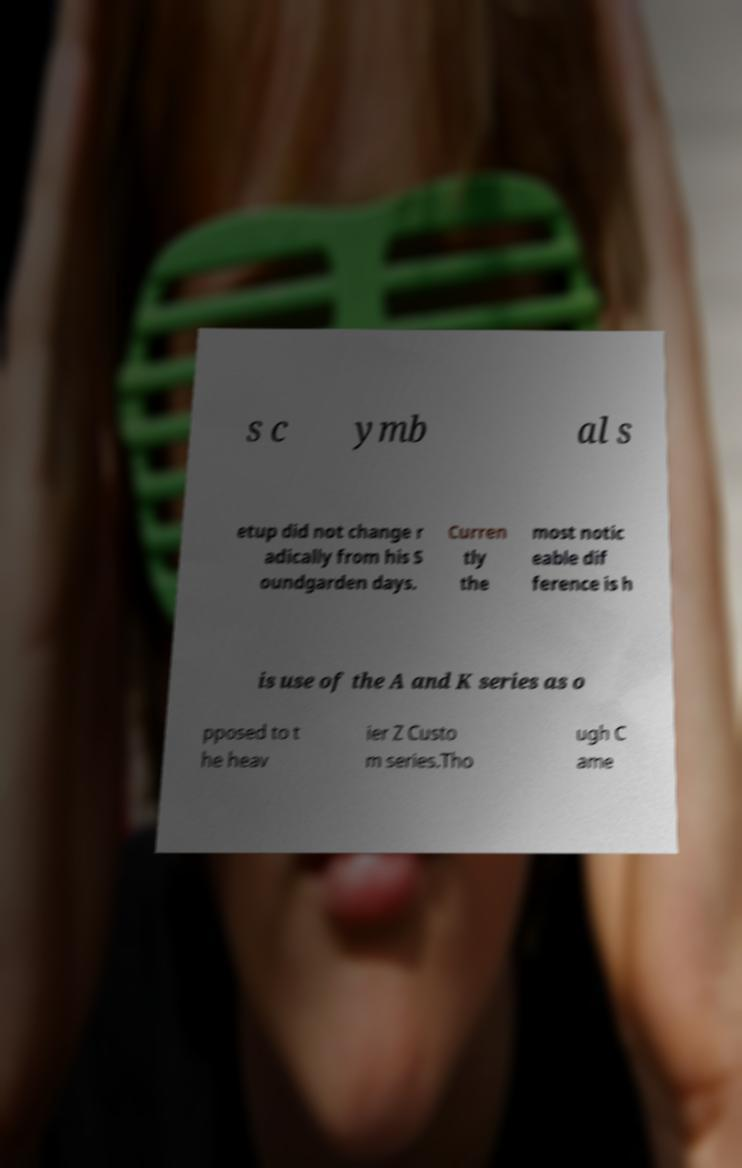Please read and relay the text visible in this image. What does it say? s c ymb al s etup did not change r adically from his S oundgarden days. Curren tly the most notic eable dif ference is h is use of the A and K series as o pposed to t he heav ier Z Custo m series.Tho ugh C ame 